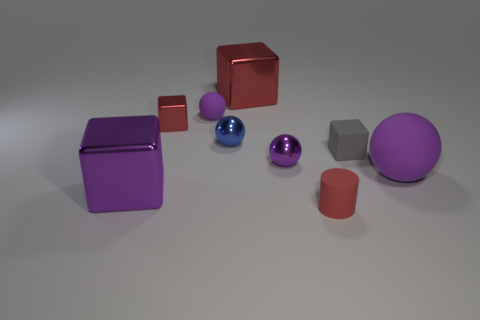What is the color of the rubber sphere that is on the right side of the matte ball that is behind the tiny red metal object?
Make the answer very short. Purple. The red thing that is in front of the large red cube and behind the small gray block is made of what material?
Ensure brevity in your answer.  Metal. Is there a small purple rubber thing that has the same shape as the large purple rubber object?
Provide a short and direct response. Yes. Is the shape of the small red object that is in front of the large purple rubber ball the same as  the small gray thing?
Provide a succinct answer. No. How many large cubes are both behind the big purple matte sphere and on the left side of the blue metal object?
Make the answer very short. 0. The gray thing on the right side of the purple block has what shape?
Your answer should be compact. Cube. What number of tiny gray balls have the same material as the tiny gray cube?
Offer a very short reply. 0. Is the shape of the tiny gray rubber object the same as the big metallic object that is in front of the tiny purple shiny ball?
Offer a terse response. Yes. Is there a object behind the block in front of the purple matte ball in front of the small purple metallic sphere?
Your response must be concise. Yes. There is a metallic block in front of the large purple rubber ball; what is its size?
Give a very brief answer. Large. 